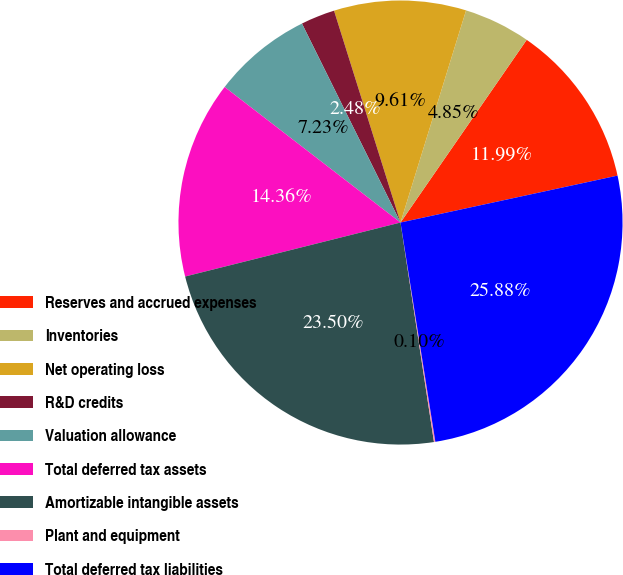Convert chart. <chart><loc_0><loc_0><loc_500><loc_500><pie_chart><fcel>Reserves and accrued expenses<fcel>Inventories<fcel>Net operating loss<fcel>R&D credits<fcel>Valuation allowance<fcel>Total deferred tax assets<fcel>Amortizable intangible assets<fcel>Plant and equipment<fcel>Total deferred tax liabilities<nl><fcel>11.99%<fcel>4.85%<fcel>9.61%<fcel>2.48%<fcel>7.23%<fcel>14.36%<fcel>23.5%<fcel>0.1%<fcel>25.88%<nl></chart> 